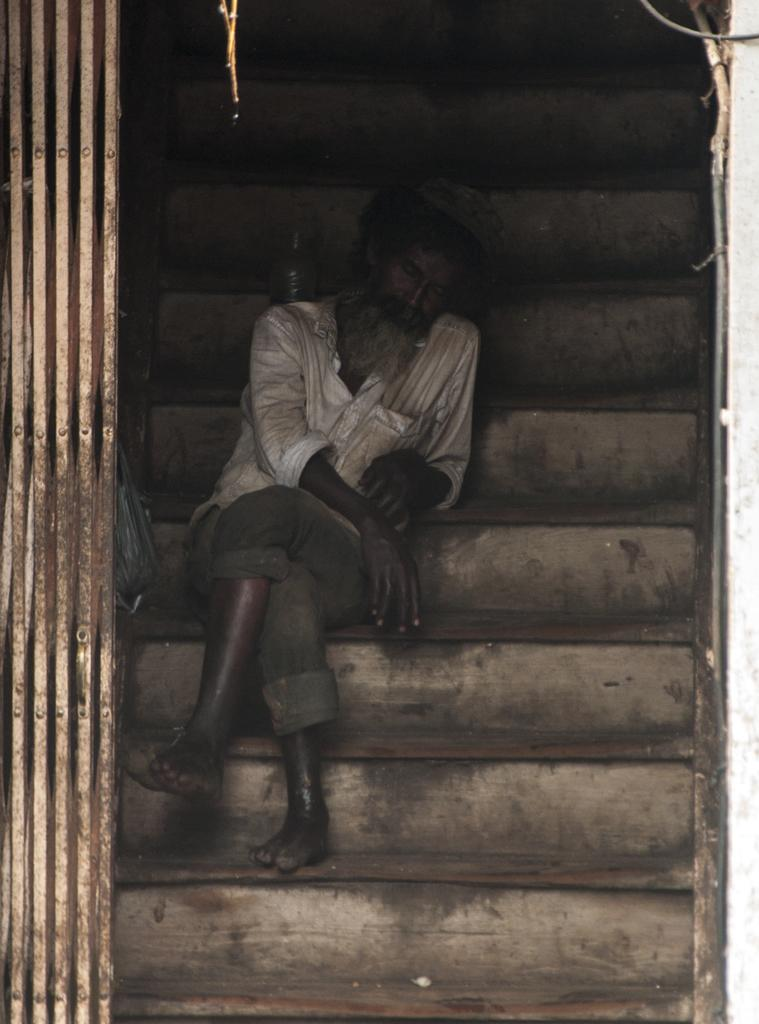What celestial objects can be seen in the image? There are stars visible in the image. What is the man in the image doing? The man is sitting on the stairs in the image. What can be seen on the left side of the image? There is a metal grill on the left side of the image. Can you tell me how many girls are drawing with chalk on the stairs in the image? There are no girls or chalk present in the image; it features a man sitting on the stairs and stars in the background. 